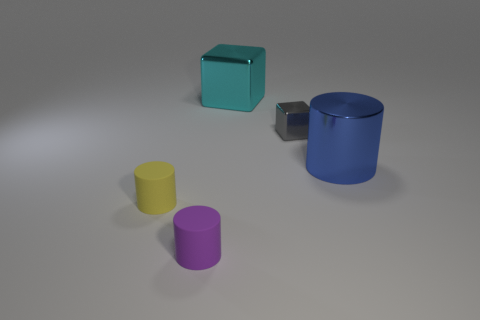Subtract all small purple cylinders. How many cylinders are left? 2 Subtract all gray cubes. How many cubes are left? 1 Subtract all cylinders. How many objects are left? 2 Add 5 red metallic cylinders. How many objects exist? 10 Subtract 1 cylinders. How many cylinders are left? 2 Subtract all green cubes. Subtract all yellow cylinders. How many cubes are left? 2 Add 2 blocks. How many blocks are left? 4 Add 3 big metallic cubes. How many big metallic cubes exist? 4 Subtract 0 purple blocks. How many objects are left? 5 Subtract all yellow cubes. How many green cylinders are left? 0 